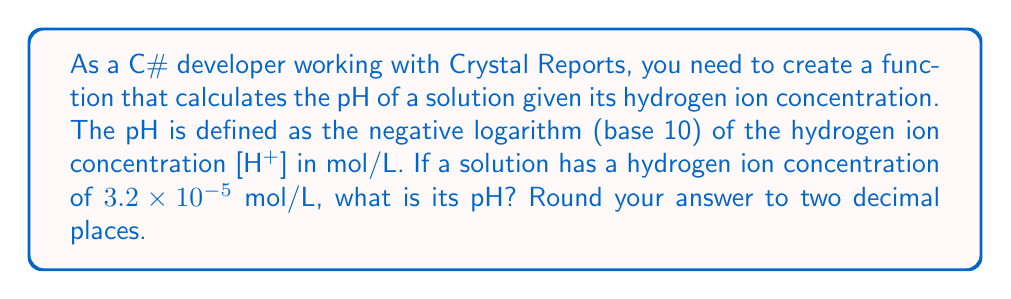Solve this math problem. To solve this problem, we'll follow these steps:

1. Recall the formula for pH:
   $$\text{pH} = -\log_{10}[\text{H}^+]$$

2. We're given that $[\text{H}^+] = 3.2 \times 10^{-5}$ mol/L

3. Substitute this value into the pH formula:
   $$\text{pH} = -\log_{10}(3.2 \times 10^{-5})$$

4. Use the logarithm property: $\log(a \times 10^n) = \log(a) + n$
   $$\text{pH} = -(\log_{10}(3.2) + \log_{10}(10^{-5}))$$
   $$\text{pH} = -(\log_{10}(3.2) - 5)$$

5. Calculate $\log_{10}(3.2)$ using a calculator or programming function:
   $$\log_{10}(3.2) \approx 0.5051$$

6. Substitute this value:
   $$\text{pH} = -(0.5051 - 5)$$
   $$\text{pH} = -0.5051 + 5$$
   $$\text{pH} = 4.4949$$

7. Round to two decimal places:
   $$\text{pH} \approx 4.49$$

In C#, you could implement this calculation as follows:

```csharp
public static double CalculatePH(double hydrogenIonConcentration)
{
    return -Math.Log10(hydrogenIonConcentration);
}

// Usage:
double concentration = 3.2e-5;
double pH = Math.Round(CalculatePH(concentration), 2);
Console.WriteLine($"The pH is {pH}");
```

This function can be used in your Crystal Reports to calculate pH values dynamically based on input data.
Answer: The pH of the solution is approximately 4.49. 